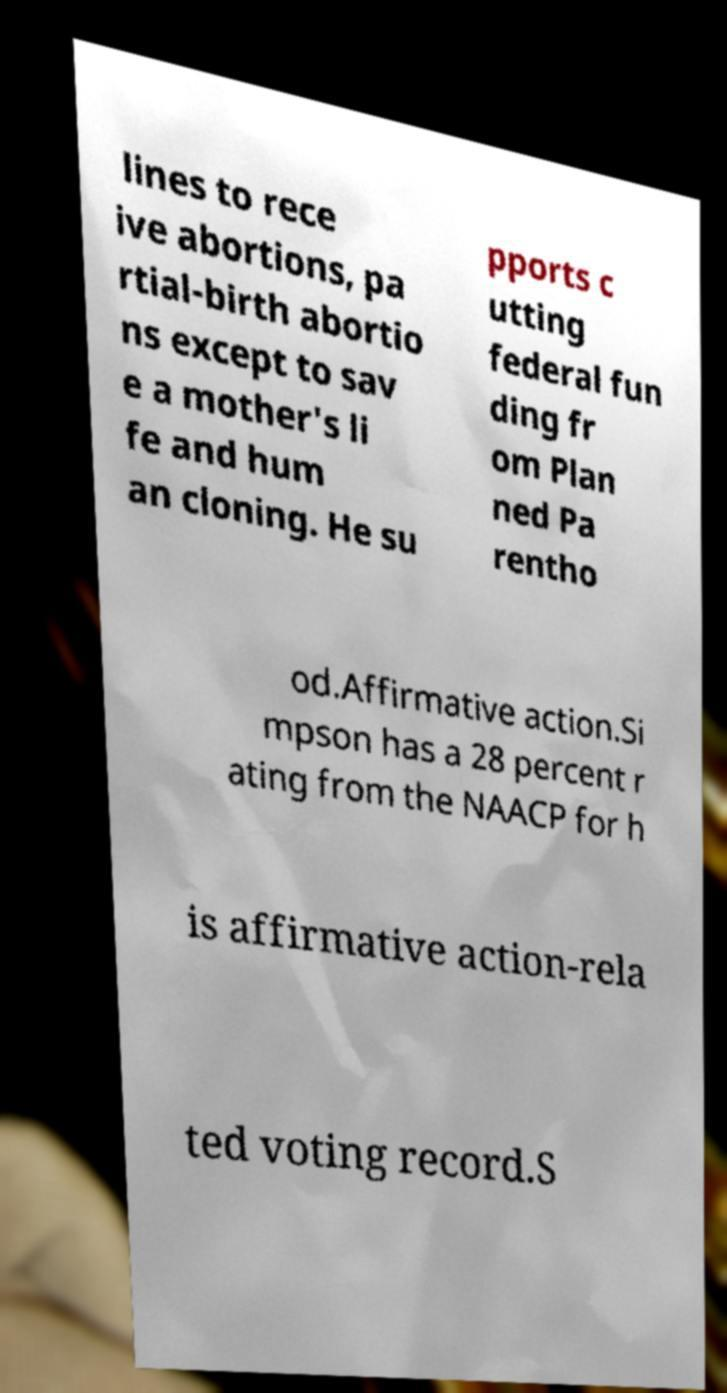I need the written content from this picture converted into text. Can you do that? lines to rece ive abortions, pa rtial-birth abortio ns except to sav e a mother's li fe and hum an cloning. He su pports c utting federal fun ding fr om Plan ned Pa rentho od.Affirmative action.Si mpson has a 28 percent r ating from the NAACP for h is affirmative action-rela ted voting record.S 